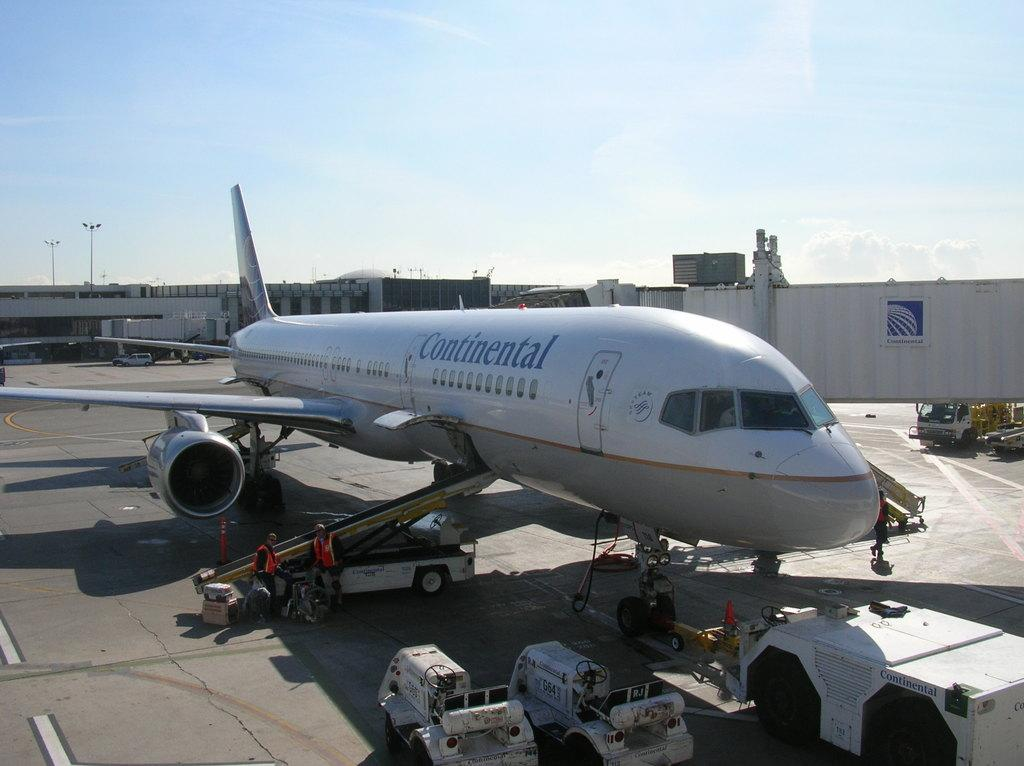<image>
Offer a succinct explanation of the picture presented. Two men wearing orange vest are putting luggage on a Continental Airplane 